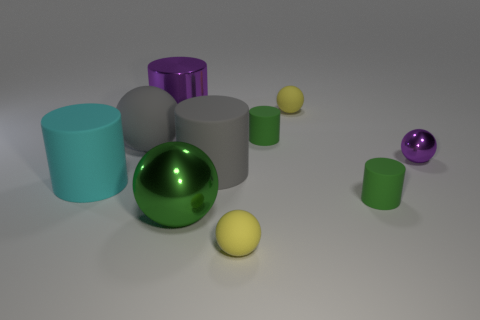Can you describe the lighting in the scene? The lighting in the scene is soft and diffused, creating gentle shadows and subtle reflections on the objects. It seems to be coming from above, possibly from a single source, given the single-direction shadows cast by the objects. 